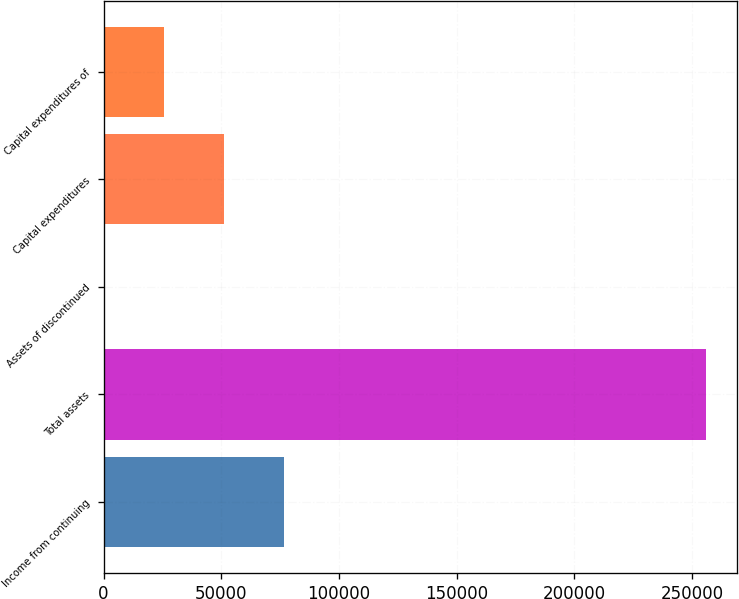<chart> <loc_0><loc_0><loc_500><loc_500><bar_chart><fcel>Income from continuing<fcel>Total assets<fcel>Assets of discontinued<fcel>Capital expenditures<fcel>Capital expenditures of<nl><fcel>76836.5<fcel>256110<fcel>4.94<fcel>51226<fcel>25615.5<nl></chart> 